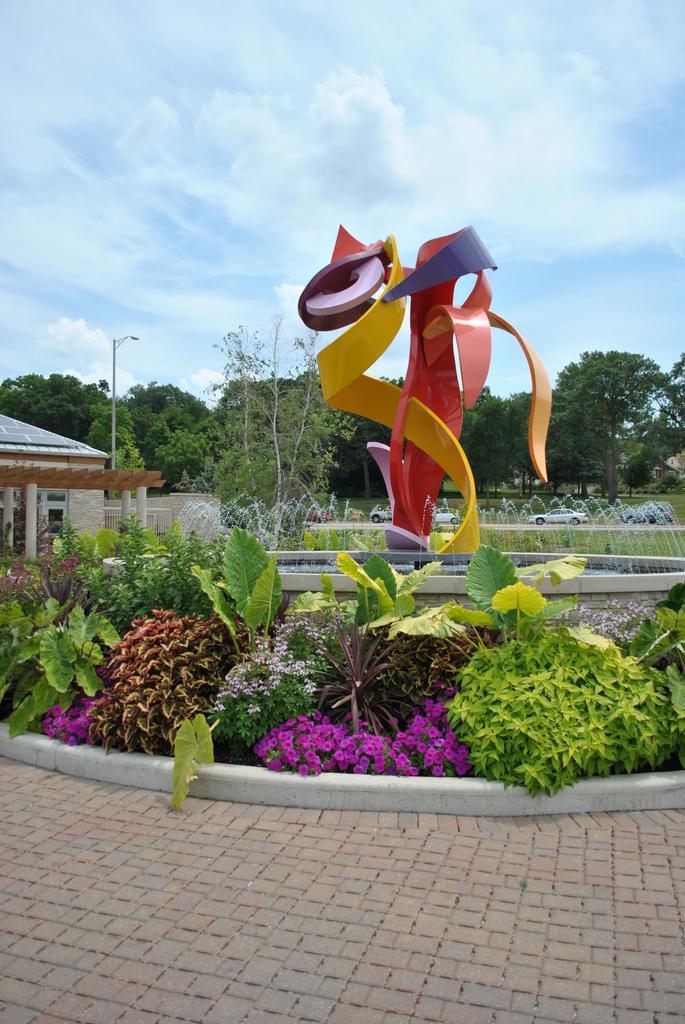In one or two sentences, can you explain what this image depicts? This is a picture taken outside the building. In the foreground of the picture there are plants, flowers, pavement, fountain and statue. In the center of the picture there are trees, cars, grass, house and a street light. Sky is bit cloudy. 